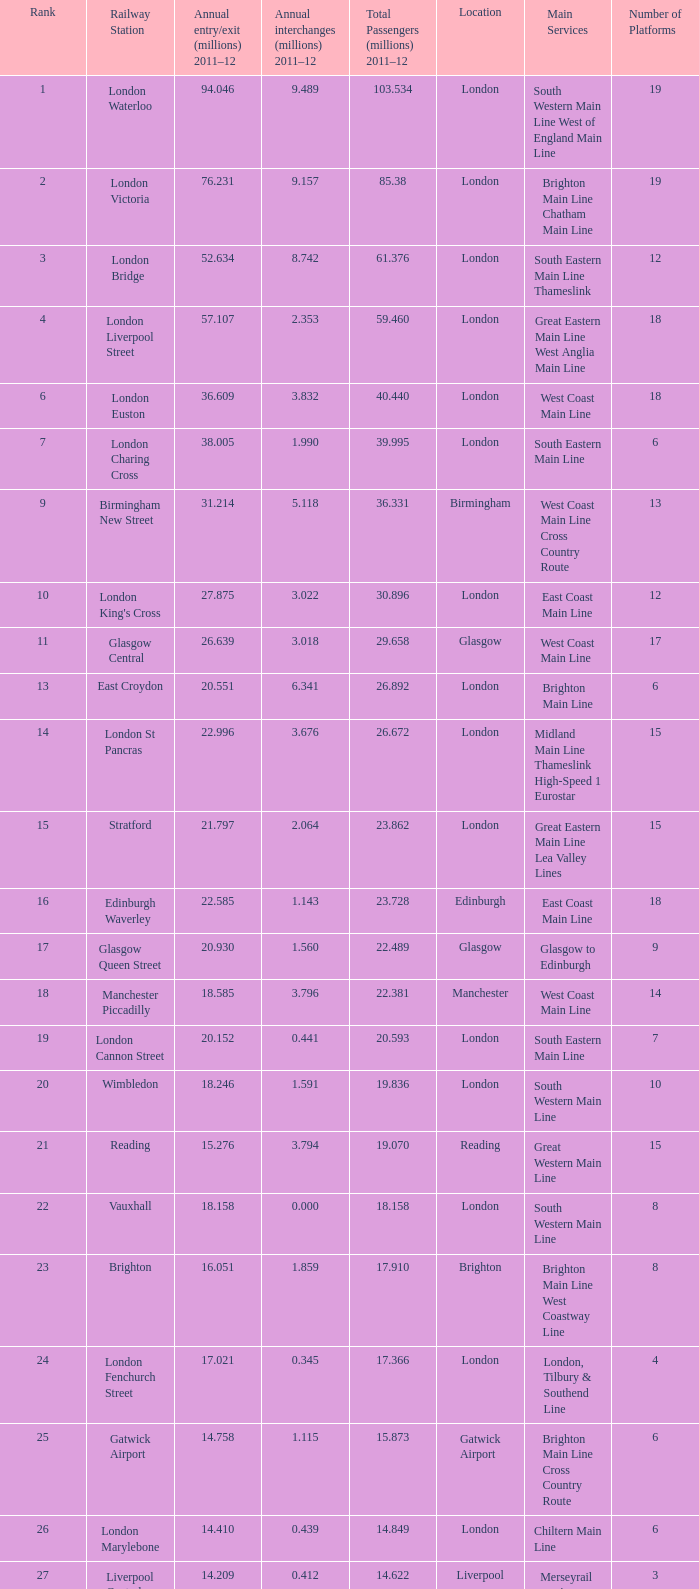534 million passengers in 2011-12? London. Would you mind parsing the complete table? {'header': ['Rank', 'Railway Station', 'Annual entry/exit (millions) 2011–12', 'Annual interchanges (millions) 2011–12', 'Total Passengers (millions) 2011–12', 'Location', 'Main Services', 'Number of Platforms'], 'rows': [['1', 'London Waterloo', '94.046', '9.489', '103.534', 'London', 'South Western Main Line West of England Main Line', '19'], ['2', 'London Victoria', '76.231', '9.157', '85.38', 'London', 'Brighton Main Line Chatham Main Line', '19'], ['3', 'London Bridge', '52.634', '8.742', '61.376', 'London', 'South Eastern Main Line Thameslink', '12'], ['4', 'London Liverpool Street', '57.107', '2.353', '59.460', 'London', 'Great Eastern Main Line West Anglia Main Line', '18'], ['6', 'London Euston', '36.609', '3.832', '40.440', 'London', 'West Coast Main Line', '18'], ['7', 'London Charing Cross', '38.005', '1.990', '39.995', 'London', 'South Eastern Main Line', '6'], ['9', 'Birmingham New Street', '31.214', '5.118', '36.331', 'Birmingham', 'West Coast Main Line Cross Country Route', '13'], ['10', "London King's Cross", '27.875', '3.022', '30.896', 'London', 'East Coast Main Line', '12'], ['11', 'Glasgow Central', '26.639', '3.018', '29.658', 'Glasgow', 'West Coast Main Line', '17'], ['13', 'East Croydon', '20.551', '6.341', '26.892', 'London', 'Brighton Main Line', '6'], ['14', 'London St Pancras', '22.996', '3.676', '26.672', 'London', 'Midland Main Line Thameslink High-Speed 1 Eurostar', '15'], ['15', 'Stratford', '21.797', '2.064', '23.862', 'London', 'Great Eastern Main Line Lea Valley Lines', '15'], ['16', 'Edinburgh Waverley', '22.585', '1.143', '23.728', 'Edinburgh', 'East Coast Main Line', '18'], ['17', 'Glasgow Queen Street', '20.930', '1.560', '22.489', 'Glasgow', 'Glasgow to Edinburgh', '9'], ['18', 'Manchester Piccadilly', '18.585', '3.796', '22.381', 'Manchester', 'West Coast Main Line', '14'], ['19', 'London Cannon Street', '20.152', '0.441', '20.593', 'London', 'South Eastern Main Line', '7'], ['20', 'Wimbledon', '18.246', '1.591', '19.836', 'London', 'South Western Main Line', '10'], ['21', 'Reading', '15.276', '3.794', '19.070', 'Reading', 'Great Western Main Line', '15'], ['22', 'Vauxhall', '18.158', '0.000', '18.158', 'London', 'South Western Main Line', '8'], ['23', 'Brighton', '16.051', '1.859', '17.910', 'Brighton', 'Brighton Main Line West Coastway Line', '8'], ['24', 'London Fenchurch Street', '17.021', '0.345', '17.366', 'London', 'London, Tilbury & Southend Line', '4'], ['25', 'Gatwick Airport', '14.758', '1.115', '15.873', 'Gatwick Airport', 'Brighton Main Line Cross Country Route', '6'], ['26', 'London Marylebone', '14.410', '0.439', '14.849', 'London', 'Chiltern Main Line', '6'], ['27', 'Liverpool Central', '14.209', '0.412', '14.622', 'Liverpool', 'Merseyrail services (Wirral and Northern lines)', '3'], ['28', 'Liverpool Lime Street', '13.835', '0.778', '14.613', 'Liverpool', 'West Coast Main Line Liverpool to Manchester Lines', '10'], ['29', 'London Blackfriars', '12.79', '1.059', '13.850', 'London', 'Thameslink', '4']]} 